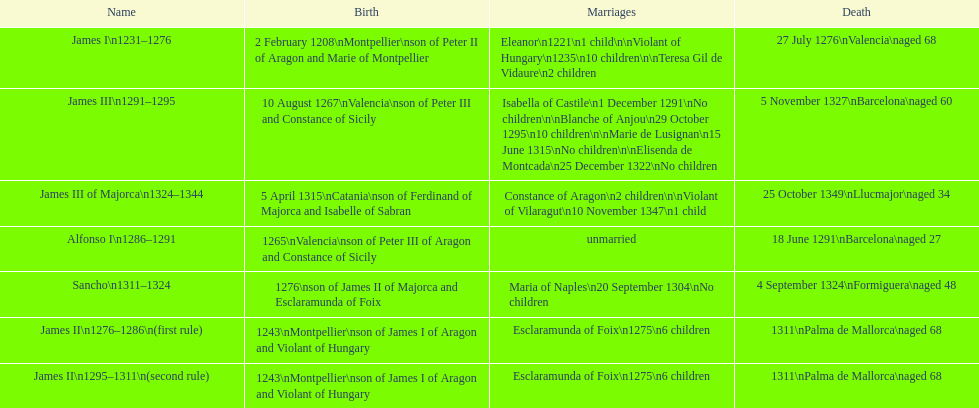Did james iii or sancho arrive in the world in the year 1276? Sancho. 